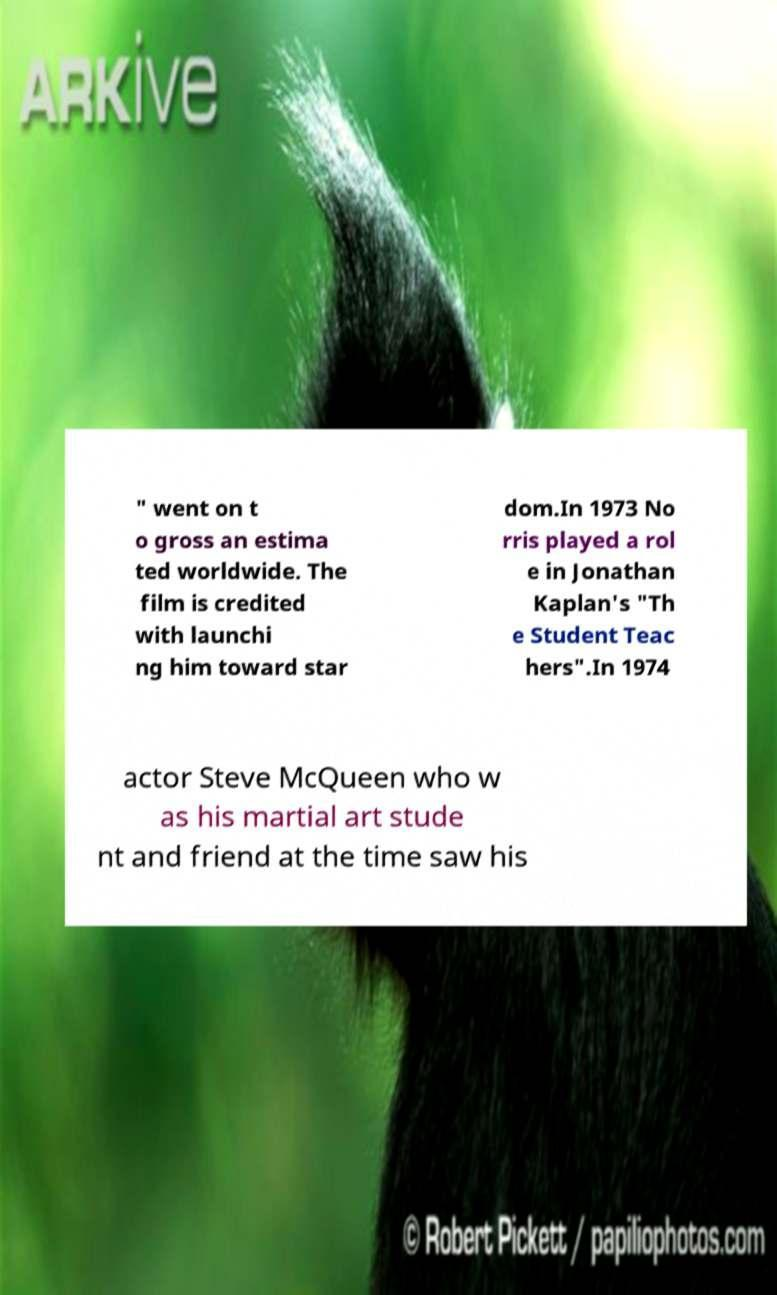I need the written content from this picture converted into text. Can you do that? " went on t o gross an estima ted worldwide. The film is credited with launchi ng him toward star dom.In 1973 No rris played a rol e in Jonathan Kaplan's "Th e Student Teac hers".In 1974 actor Steve McQueen who w as his martial art stude nt and friend at the time saw his 